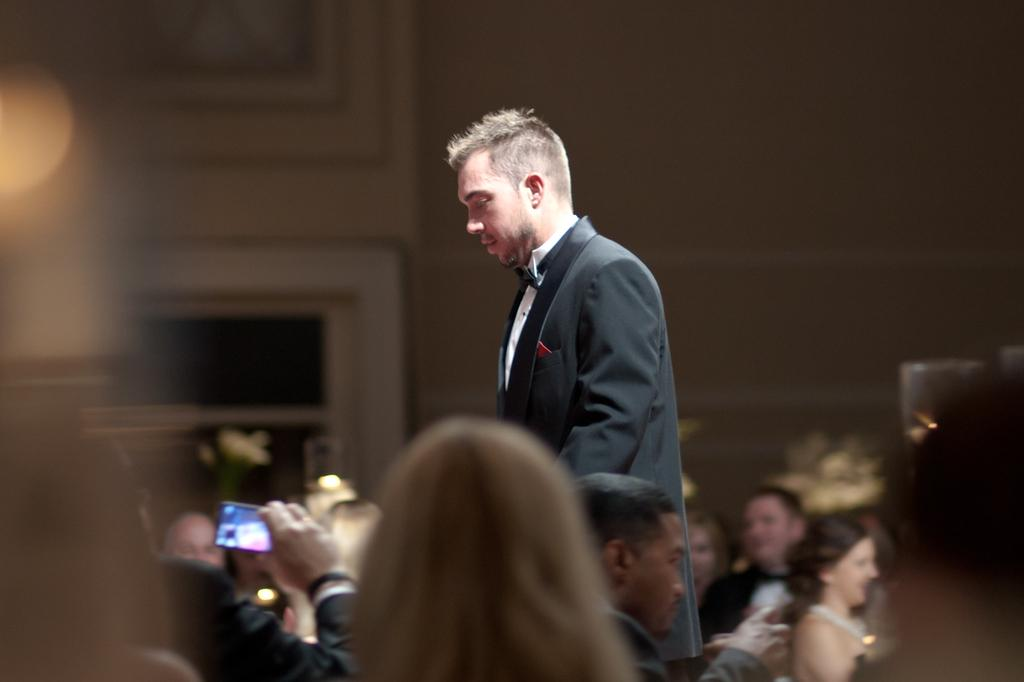What is the main subject in the center of the image? There is a man standing in the center of the image. Are there any other people visible in the image? Yes, there are people at the bottom side of the image. What can be seen in the background of the image? It appears that there are windows in the background. Can you describe the lighting in the image? There is a light shadow in the background. What type of pin is being used to hold the roof in place in the image? There is no pin or roof present in the image; it features a man and people in a setting with windows and a light shadow in the background. 